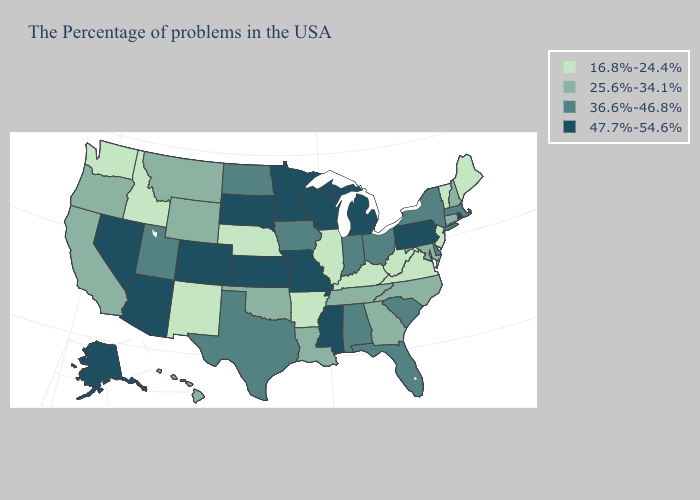Is the legend a continuous bar?
Keep it brief. No. What is the value of Montana?
Answer briefly. 25.6%-34.1%. What is the highest value in states that border New Jersey?
Concise answer only. 47.7%-54.6%. Does Wisconsin have the highest value in the USA?
Write a very short answer. Yes. Which states have the lowest value in the USA?
Write a very short answer. Maine, Vermont, New Jersey, Virginia, West Virginia, Kentucky, Illinois, Arkansas, Nebraska, New Mexico, Idaho, Washington. Does Connecticut have a lower value than Wisconsin?
Be succinct. Yes. Name the states that have a value in the range 16.8%-24.4%?
Short answer required. Maine, Vermont, New Jersey, Virginia, West Virginia, Kentucky, Illinois, Arkansas, Nebraska, New Mexico, Idaho, Washington. What is the highest value in states that border Oklahoma?
Write a very short answer. 47.7%-54.6%. Name the states that have a value in the range 16.8%-24.4%?
Concise answer only. Maine, Vermont, New Jersey, Virginia, West Virginia, Kentucky, Illinois, Arkansas, Nebraska, New Mexico, Idaho, Washington. Does Utah have a higher value than Louisiana?
Write a very short answer. Yes. Which states have the lowest value in the USA?
Keep it brief. Maine, Vermont, New Jersey, Virginia, West Virginia, Kentucky, Illinois, Arkansas, Nebraska, New Mexico, Idaho, Washington. Name the states that have a value in the range 16.8%-24.4%?
Keep it brief. Maine, Vermont, New Jersey, Virginia, West Virginia, Kentucky, Illinois, Arkansas, Nebraska, New Mexico, Idaho, Washington. What is the value of Hawaii?
Give a very brief answer. 25.6%-34.1%. Name the states that have a value in the range 16.8%-24.4%?
Keep it brief. Maine, Vermont, New Jersey, Virginia, West Virginia, Kentucky, Illinois, Arkansas, Nebraska, New Mexico, Idaho, Washington. Among the states that border Utah , which have the lowest value?
Give a very brief answer. New Mexico, Idaho. 